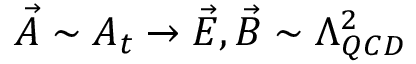<formula> <loc_0><loc_0><loc_500><loc_500>\vec { A } \sim A _ { t } \rightarrow \vec { E } , \vec { B } \sim \Lambda _ { Q C D } ^ { 2 }</formula> 